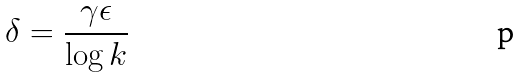Convert formula to latex. <formula><loc_0><loc_0><loc_500><loc_500>\delta = \frac { \gamma \epsilon } { \log k }</formula> 